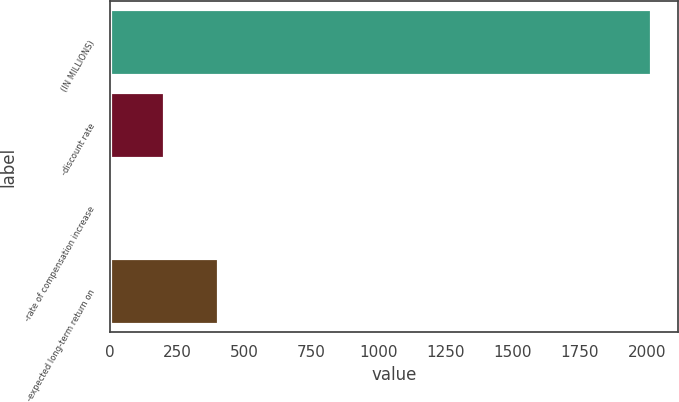<chart> <loc_0><loc_0><loc_500><loc_500><bar_chart><fcel>(IN MILLIONS)<fcel>-discount rate<fcel>-rate of compensation increase<fcel>-expected long-term return on<nl><fcel>2015<fcel>203.03<fcel>1.7<fcel>404.36<nl></chart> 